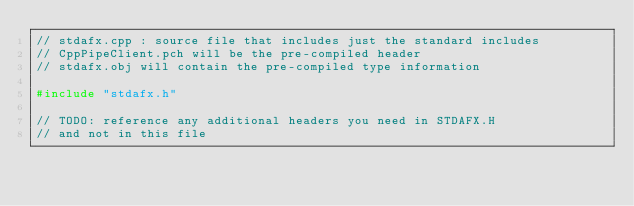<code> <loc_0><loc_0><loc_500><loc_500><_C++_>// stdafx.cpp : source file that includes just the standard includes
// CppPipeClient.pch will be the pre-compiled header
// stdafx.obj will contain the pre-compiled type information

#include "stdafx.h"

// TODO: reference any additional headers you need in STDAFX.H
// and not in this file
</code> 